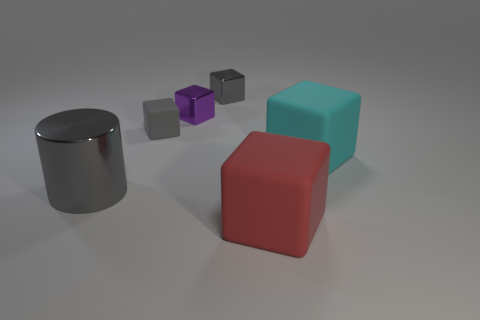Subtract all big red matte blocks. How many blocks are left? 4 Add 3 purple rubber objects. How many objects exist? 9 Subtract 4 blocks. How many blocks are left? 1 Subtract all gray blocks. How many blocks are left? 3 Add 3 big red rubber blocks. How many big red rubber blocks are left? 4 Add 3 small things. How many small things exist? 6 Subtract 0 cyan cylinders. How many objects are left? 6 Subtract all cylinders. How many objects are left? 5 Subtract all purple cubes. Subtract all yellow spheres. How many cubes are left? 4 Subtract all green cylinders. How many yellow cubes are left? 0 